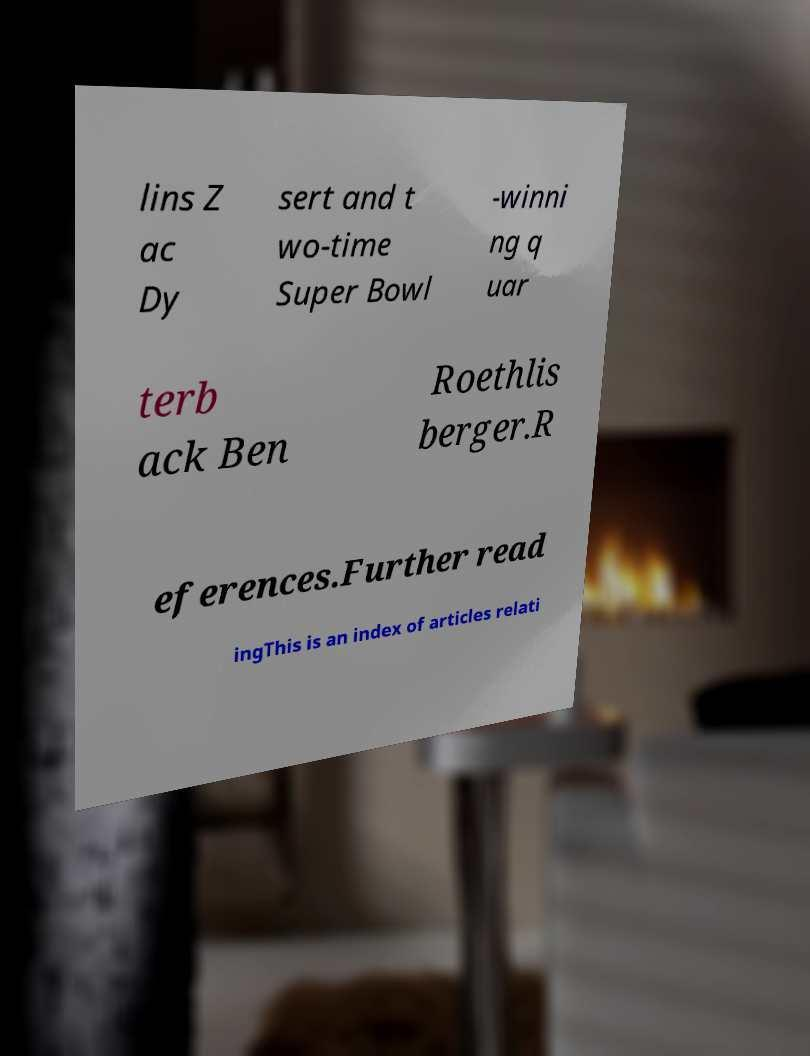For documentation purposes, I need the text within this image transcribed. Could you provide that? lins Z ac Dy sert and t wo-time Super Bowl -winni ng q uar terb ack Ben Roethlis berger.R eferences.Further read ingThis is an index of articles relati 